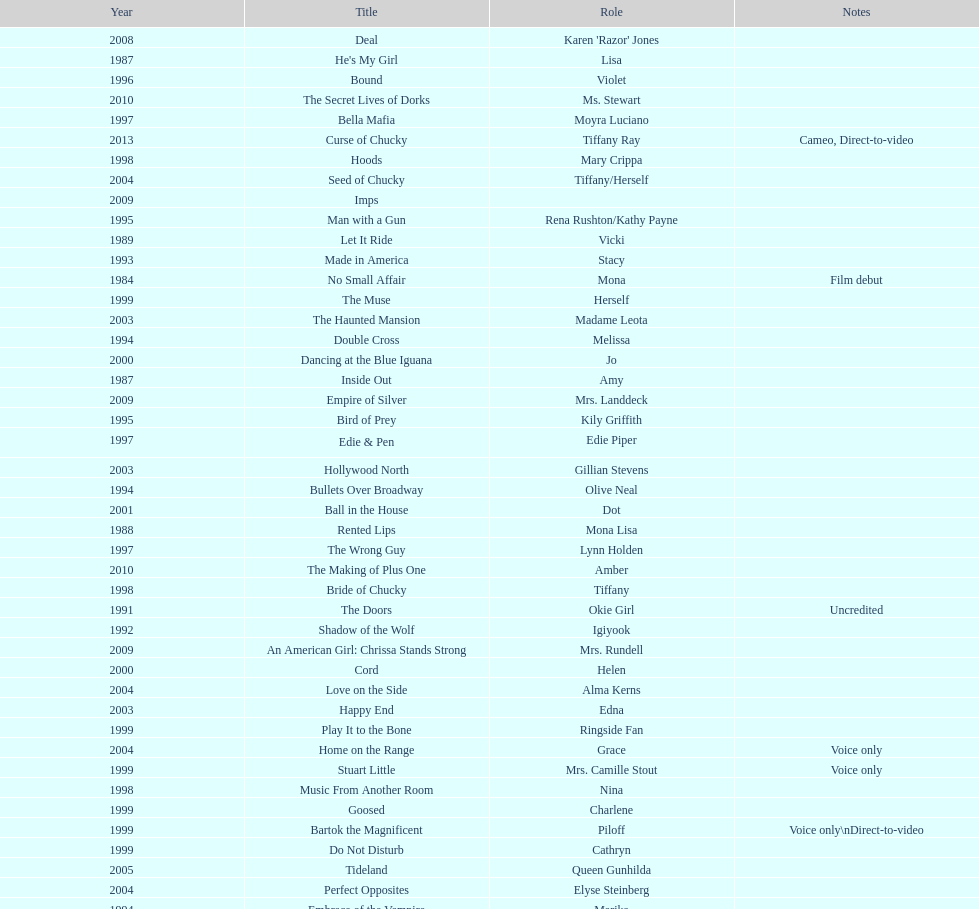How many rolls did jennifer tilly play in the 1980s? 11. 